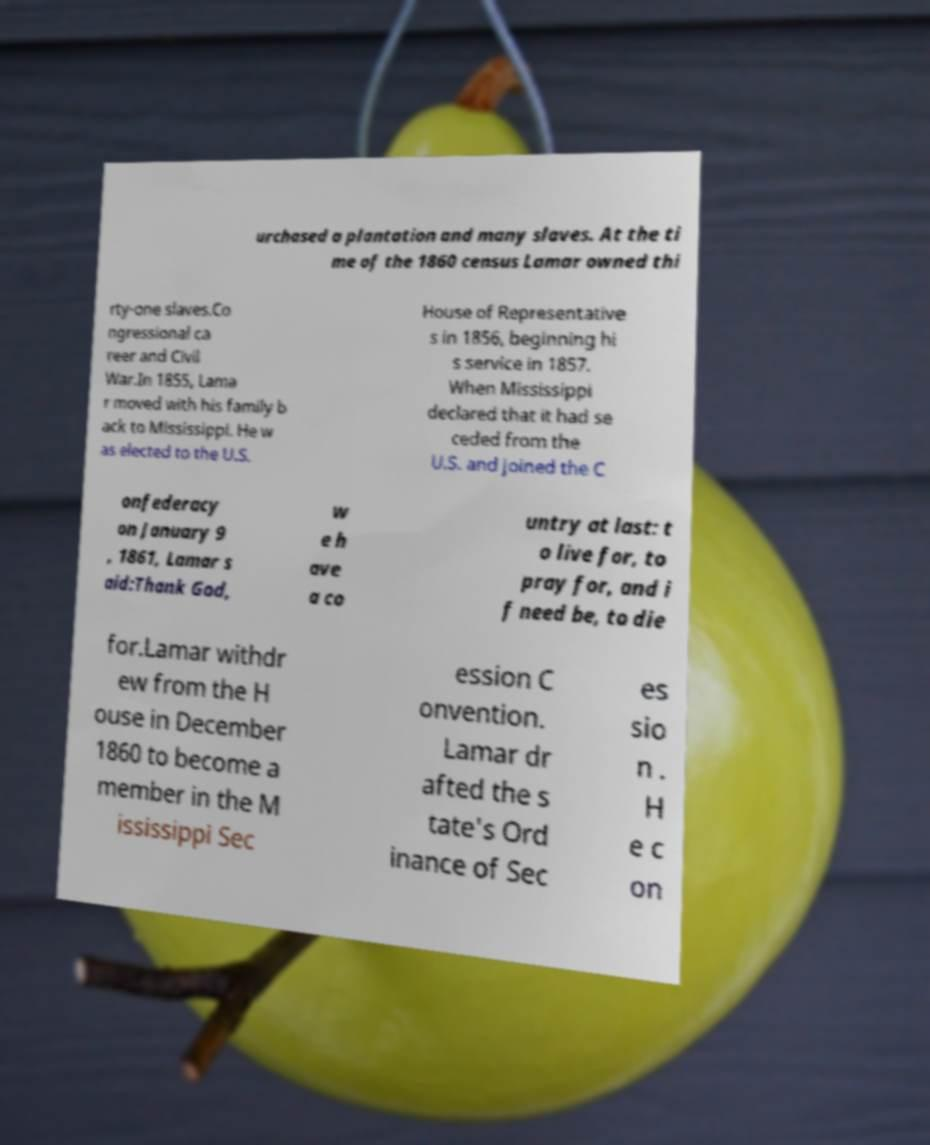I need the written content from this picture converted into text. Can you do that? urchased a plantation and many slaves. At the ti me of the 1860 census Lamar owned thi rty-one slaves.Co ngressional ca reer and Civil War.In 1855, Lama r moved with his family b ack to Mississippi. He w as elected to the U.S. House of Representative s in 1856, beginning hi s service in 1857. When Mississippi declared that it had se ceded from the U.S. and joined the C onfederacy on January 9 , 1861, Lamar s aid:Thank God, w e h ave a co untry at last: t o live for, to pray for, and i f need be, to die for.Lamar withdr ew from the H ouse in December 1860 to become a member in the M ississippi Sec ession C onvention. Lamar dr afted the s tate's Ord inance of Sec es sio n . H e c on 